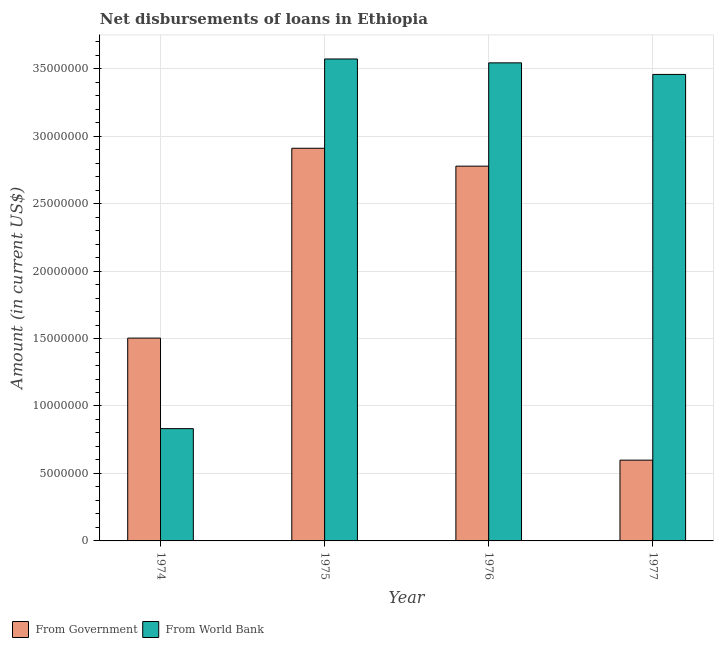How many groups of bars are there?
Provide a succinct answer. 4. Are the number of bars on each tick of the X-axis equal?
Keep it short and to the point. Yes. How many bars are there on the 3rd tick from the right?
Offer a very short reply. 2. In how many cases, is the number of bars for a given year not equal to the number of legend labels?
Ensure brevity in your answer.  0. What is the net disbursements of loan from world bank in 1975?
Your response must be concise. 3.57e+07. Across all years, what is the maximum net disbursements of loan from government?
Provide a short and direct response. 2.91e+07. Across all years, what is the minimum net disbursements of loan from world bank?
Make the answer very short. 8.32e+06. In which year was the net disbursements of loan from government maximum?
Provide a short and direct response. 1975. In which year was the net disbursements of loan from world bank minimum?
Your answer should be very brief. 1974. What is the total net disbursements of loan from world bank in the graph?
Offer a terse response. 1.14e+08. What is the difference between the net disbursements of loan from government in 1974 and that in 1975?
Give a very brief answer. -1.41e+07. What is the difference between the net disbursements of loan from world bank in 1975 and the net disbursements of loan from government in 1977?
Ensure brevity in your answer.  1.15e+06. What is the average net disbursements of loan from world bank per year?
Your answer should be very brief. 2.85e+07. In how many years, is the net disbursements of loan from world bank greater than 19000000 US$?
Provide a succinct answer. 3. What is the ratio of the net disbursements of loan from world bank in 1974 to that in 1976?
Give a very brief answer. 0.23. Is the net disbursements of loan from world bank in 1975 less than that in 1976?
Your answer should be very brief. No. Is the difference between the net disbursements of loan from world bank in 1975 and 1976 greater than the difference between the net disbursements of loan from government in 1975 and 1976?
Ensure brevity in your answer.  No. What is the difference between the highest and the second highest net disbursements of loan from government?
Provide a short and direct response. 1.33e+06. What is the difference between the highest and the lowest net disbursements of loan from government?
Your answer should be very brief. 2.31e+07. In how many years, is the net disbursements of loan from world bank greater than the average net disbursements of loan from world bank taken over all years?
Your answer should be compact. 3. What does the 2nd bar from the left in 1976 represents?
Your answer should be compact. From World Bank. What does the 2nd bar from the right in 1976 represents?
Offer a very short reply. From Government. What is the difference between two consecutive major ticks on the Y-axis?
Keep it short and to the point. 5.00e+06. Are the values on the major ticks of Y-axis written in scientific E-notation?
Your answer should be very brief. No. Does the graph contain any zero values?
Keep it short and to the point. No. Does the graph contain grids?
Your response must be concise. Yes. Where does the legend appear in the graph?
Make the answer very short. Bottom left. What is the title of the graph?
Offer a terse response. Net disbursements of loans in Ethiopia. What is the label or title of the Y-axis?
Ensure brevity in your answer.  Amount (in current US$). What is the Amount (in current US$) of From Government in 1974?
Offer a terse response. 1.50e+07. What is the Amount (in current US$) of From World Bank in 1974?
Your answer should be compact. 8.32e+06. What is the Amount (in current US$) in From Government in 1975?
Your answer should be compact. 2.91e+07. What is the Amount (in current US$) in From World Bank in 1975?
Your response must be concise. 3.57e+07. What is the Amount (in current US$) in From Government in 1976?
Offer a terse response. 2.78e+07. What is the Amount (in current US$) in From World Bank in 1976?
Offer a terse response. 3.54e+07. What is the Amount (in current US$) of From Government in 1977?
Ensure brevity in your answer.  5.99e+06. What is the Amount (in current US$) of From World Bank in 1977?
Your response must be concise. 3.46e+07. Across all years, what is the maximum Amount (in current US$) in From Government?
Provide a short and direct response. 2.91e+07. Across all years, what is the maximum Amount (in current US$) in From World Bank?
Make the answer very short. 3.57e+07. Across all years, what is the minimum Amount (in current US$) in From Government?
Offer a very short reply. 5.99e+06. Across all years, what is the minimum Amount (in current US$) of From World Bank?
Your answer should be very brief. 8.32e+06. What is the total Amount (in current US$) of From Government in the graph?
Offer a terse response. 7.79e+07. What is the total Amount (in current US$) of From World Bank in the graph?
Your answer should be compact. 1.14e+08. What is the difference between the Amount (in current US$) in From Government in 1974 and that in 1975?
Your answer should be very brief. -1.41e+07. What is the difference between the Amount (in current US$) of From World Bank in 1974 and that in 1975?
Make the answer very short. -2.74e+07. What is the difference between the Amount (in current US$) of From Government in 1974 and that in 1976?
Your answer should be very brief. -1.27e+07. What is the difference between the Amount (in current US$) in From World Bank in 1974 and that in 1976?
Offer a very short reply. -2.71e+07. What is the difference between the Amount (in current US$) in From Government in 1974 and that in 1977?
Ensure brevity in your answer.  9.04e+06. What is the difference between the Amount (in current US$) of From World Bank in 1974 and that in 1977?
Your answer should be compact. -2.62e+07. What is the difference between the Amount (in current US$) of From Government in 1975 and that in 1976?
Your answer should be compact. 1.33e+06. What is the difference between the Amount (in current US$) in From World Bank in 1975 and that in 1976?
Keep it short and to the point. 2.87e+05. What is the difference between the Amount (in current US$) in From Government in 1975 and that in 1977?
Your response must be concise. 2.31e+07. What is the difference between the Amount (in current US$) of From World Bank in 1975 and that in 1977?
Offer a very short reply. 1.15e+06. What is the difference between the Amount (in current US$) of From Government in 1976 and that in 1977?
Provide a short and direct response. 2.18e+07. What is the difference between the Amount (in current US$) in From World Bank in 1976 and that in 1977?
Make the answer very short. 8.59e+05. What is the difference between the Amount (in current US$) of From Government in 1974 and the Amount (in current US$) of From World Bank in 1975?
Your answer should be compact. -2.07e+07. What is the difference between the Amount (in current US$) of From Government in 1974 and the Amount (in current US$) of From World Bank in 1976?
Ensure brevity in your answer.  -2.04e+07. What is the difference between the Amount (in current US$) in From Government in 1974 and the Amount (in current US$) in From World Bank in 1977?
Provide a succinct answer. -1.95e+07. What is the difference between the Amount (in current US$) of From Government in 1975 and the Amount (in current US$) of From World Bank in 1976?
Ensure brevity in your answer.  -6.33e+06. What is the difference between the Amount (in current US$) in From Government in 1975 and the Amount (in current US$) in From World Bank in 1977?
Your answer should be compact. -5.47e+06. What is the difference between the Amount (in current US$) of From Government in 1976 and the Amount (in current US$) of From World Bank in 1977?
Your response must be concise. -6.80e+06. What is the average Amount (in current US$) of From Government per year?
Offer a terse response. 1.95e+07. What is the average Amount (in current US$) in From World Bank per year?
Provide a short and direct response. 2.85e+07. In the year 1974, what is the difference between the Amount (in current US$) of From Government and Amount (in current US$) of From World Bank?
Make the answer very short. 6.71e+06. In the year 1975, what is the difference between the Amount (in current US$) in From Government and Amount (in current US$) in From World Bank?
Offer a very short reply. -6.62e+06. In the year 1976, what is the difference between the Amount (in current US$) of From Government and Amount (in current US$) of From World Bank?
Provide a short and direct response. -7.66e+06. In the year 1977, what is the difference between the Amount (in current US$) of From Government and Amount (in current US$) of From World Bank?
Your answer should be very brief. -2.86e+07. What is the ratio of the Amount (in current US$) of From Government in 1974 to that in 1975?
Your response must be concise. 0.52. What is the ratio of the Amount (in current US$) in From World Bank in 1974 to that in 1975?
Provide a succinct answer. 0.23. What is the ratio of the Amount (in current US$) of From Government in 1974 to that in 1976?
Your answer should be compact. 0.54. What is the ratio of the Amount (in current US$) of From World Bank in 1974 to that in 1976?
Keep it short and to the point. 0.23. What is the ratio of the Amount (in current US$) of From Government in 1974 to that in 1977?
Ensure brevity in your answer.  2.51. What is the ratio of the Amount (in current US$) in From World Bank in 1974 to that in 1977?
Offer a terse response. 0.24. What is the ratio of the Amount (in current US$) of From Government in 1975 to that in 1976?
Ensure brevity in your answer.  1.05. What is the ratio of the Amount (in current US$) of From World Bank in 1975 to that in 1976?
Offer a terse response. 1.01. What is the ratio of the Amount (in current US$) of From Government in 1975 to that in 1977?
Offer a very short reply. 4.86. What is the ratio of the Amount (in current US$) of From World Bank in 1975 to that in 1977?
Offer a terse response. 1.03. What is the ratio of the Amount (in current US$) of From Government in 1976 to that in 1977?
Give a very brief answer. 4.64. What is the ratio of the Amount (in current US$) in From World Bank in 1976 to that in 1977?
Keep it short and to the point. 1.02. What is the difference between the highest and the second highest Amount (in current US$) in From Government?
Your answer should be compact. 1.33e+06. What is the difference between the highest and the second highest Amount (in current US$) of From World Bank?
Keep it short and to the point. 2.87e+05. What is the difference between the highest and the lowest Amount (in current US$) in From Government?
Your answer should be very brief. 2.31e+07. What is the difference between the highest and the lowest Amount (in current US$) in From World Bank?
Provide a short and direct response. 2.74e+07. 